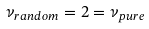<formula> <loc_0><loc_0><loc_500><loc_500>\nu _ { r a n d o m } = 2 = \nu _ { p u r e }</formula> 